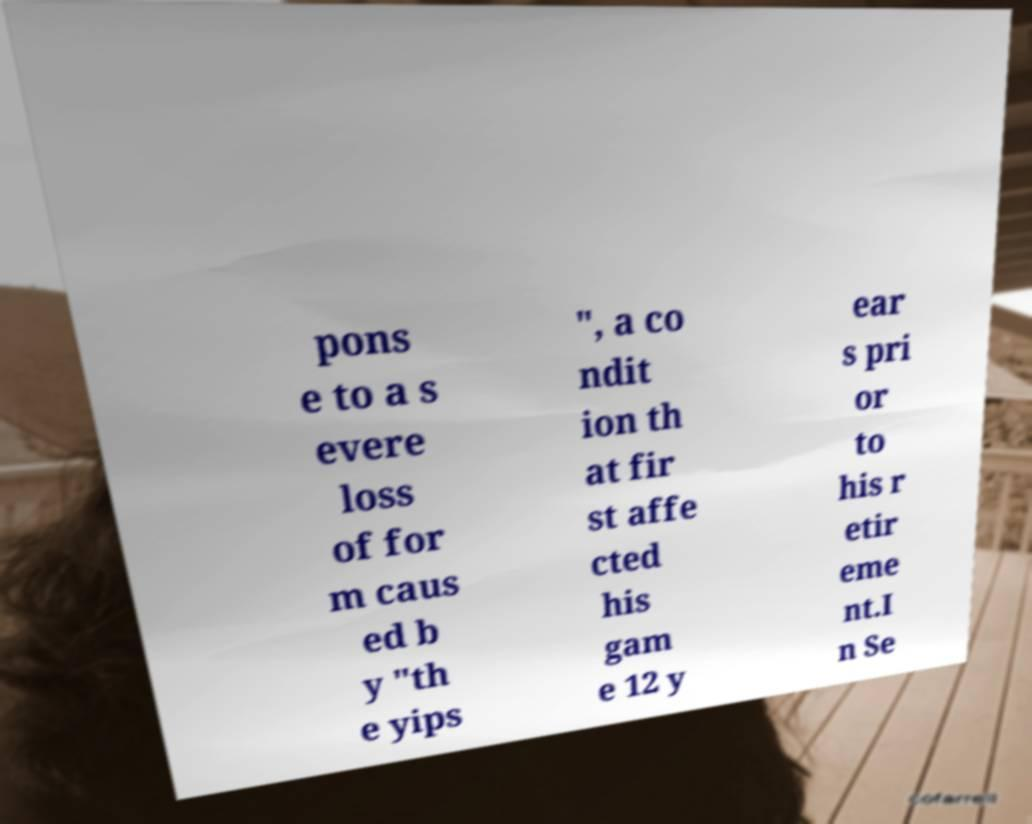Please read and relay the text visible in this image. What does it say? pons e to a s evere loss of for m caus ed b y "th e yips ", a co ndit ion th at fir st affe cted his gam e 12 y ear s pri or to his r etir eme nt.I n Se 